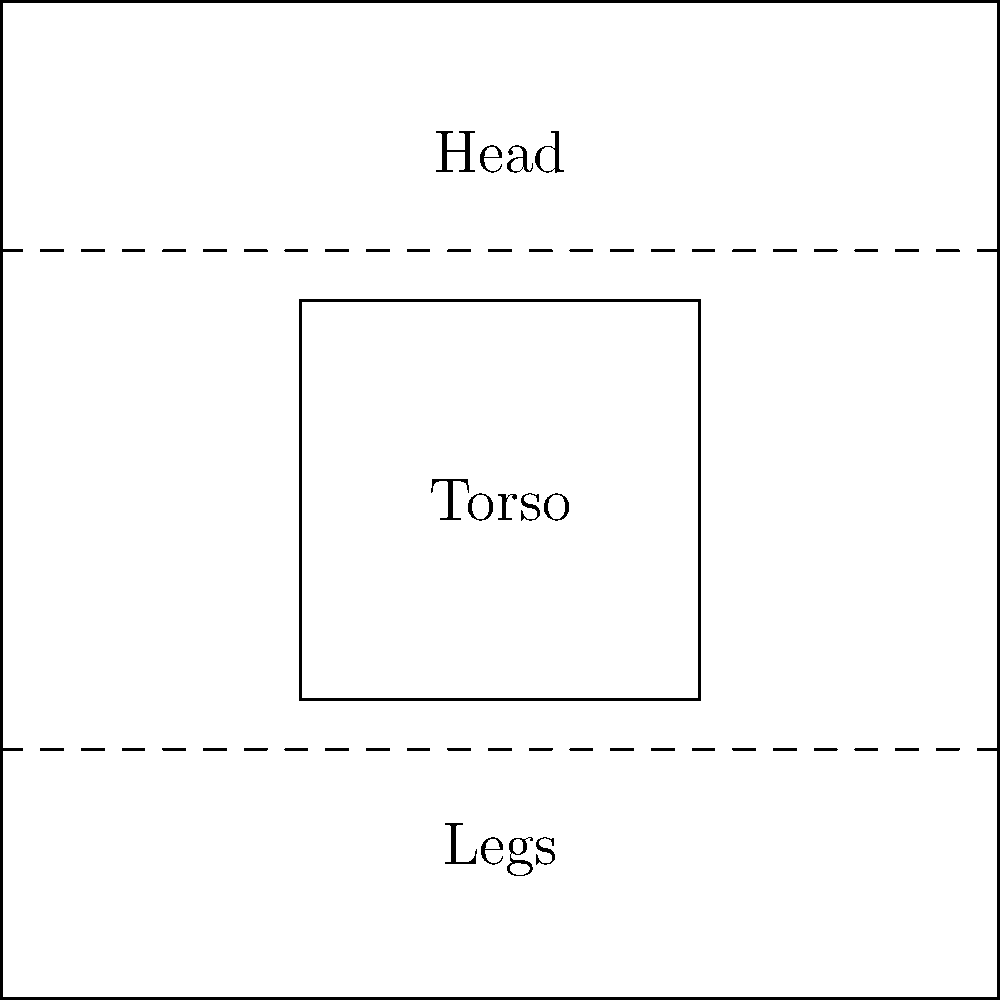In classical figure drawing, the human body is often divided into proportions for accurate representation. According to the standard canon of proportions, how many "head lengths" typically comprise the total height of an idealized adult human figure? To answer this question, let's break down the classical approach to figure proportions:

1. In traditional academic art, the human figure is often divided into units based on the length of the head.

2. This system, known as the "canon of proportions," was developed and refined by artists and anatomists over centuries.

3. The most commonly used proportion in classical figure drawing divides the human body into 8 equal parts, each equal to the length of the head.

4. These 8 parts are typically distributed as follows:
   - 1 unit for the head itself
   - 3 units for the torso (from the chin to the hip joint)
   - 4 units for the legs (from the hip joint to the feet)

5. This 8-head proportion creates an idealized, heroic figure that is slightly taller than the average human.

6. It's important to note that these proportions are guidelines and not strict rules. Real human bodies vary, and artists often adjust proportions for stylistic or expressive purposes.

7. However, understanding this classical canon provides a foundation for figure drawing and helps artists create balanced, aesthetically pleasing representations of the human form.

Therefore, according to the classical canon of proportions, the total height of an idealized adult human figure is typically 8 head lengths.
Answer: 8 head lengths 